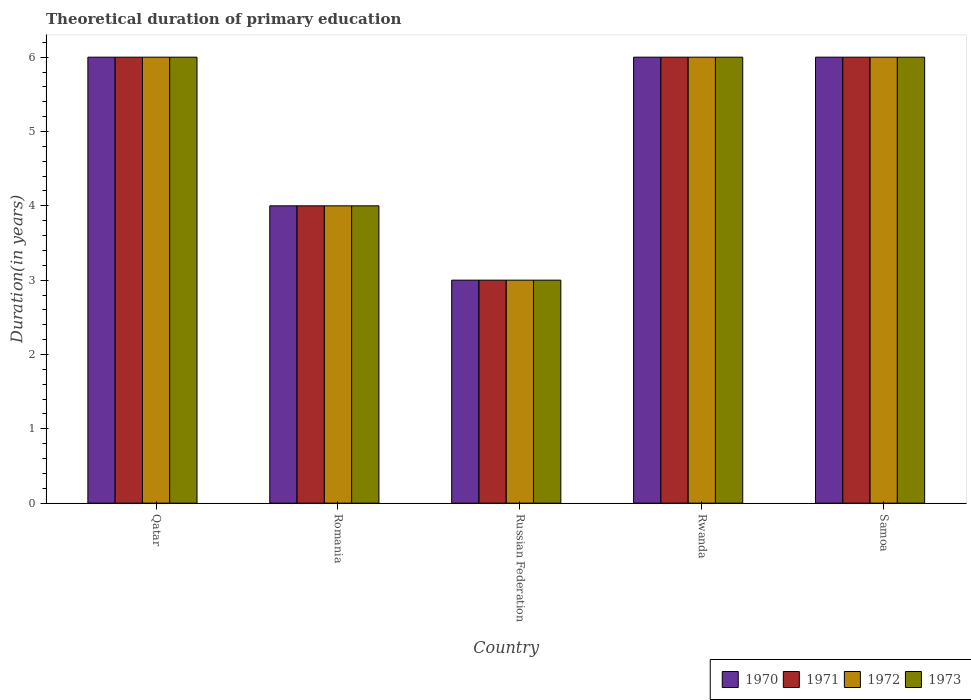How many different coloured bars are there?
Provide a short and direct response. 4. How many groups of bars are there?
Offer a very short reply. 5. Are the number of bars per tick equal to the number of legend labels?
Ensure brevity in your answer.  Yes. What is the label of the 1st group of bars from the left?
Provide a succinct answer. Qatar. In which country was the total theoretical duration of primary education in 1971 maximum?
Offer a terse response. Qatar. In which country was the total theoretical duration of primary education in 1971 minimum?
Your answer should be very brief. Russian Federation. What is the total total theoretical duration of primary education in 1971 in the graph?
Provide a short and direct response. 25. What is the difference between the total theoretical duration of primary education in 1973 in Qatar and that in Romania?
Make the answer very short. 2. In how many countries, is the total theoretical duration of primary education in 1973 greater than 4.2 years?
Offer a terse response. 3. What is the ratio of the total theoretical duration of primary education in 1970 in Rwanda to that in Samoa?
Give a very brief answer. 1. Is the total theoretical duration of primary education in 1970 in Qatar less than that in Russian Federation?
Provide a short and direct response. No. Is the difference between the total theoretical duration of primary education in 1971 in Romania and Samoa greater than the difference between the total theoretical duration of primary education in 1973 in Romania and Samoa?
Give a very brief answer. No. Is it the case that in every country, the sum of the total theoretical duration of primary education in 1970 and total theoretical duration of primary education in 1972 is greater than the sum of total theoretical duration of primary education in 1971 and total theoretical duration of primary education in 1973?
Your answer should be very brief. No. What does the 4th bar from the left in Qatar represents?
Your answer should be very brief. 1973. What does the 3rd bar from the right in Russian Federation represents?
Your answer should be very brief. 1971. How many bars are there?
Make the answer very short. 20. Are all the bars in the graph horizontal?
Your response must be concise. No. What is the difference between two consecutive major ticks on the Y-axis?
Provide a short and direct response. 1. Does the graph contain any zero values?
Offer a terse response. No. Where does the legend appear in the graph?
Offer a very short reply. Bottom right. How many legend labels are there?
Provide a succinct answer. 4. What is the title of the graph?
Provide a short and direct response. Theoretical duration of primary education. What is the label or title of the Y-axis?
Provide a short and direct response. Duration(in years). What is the Duration(in years) in 1970 in Qatar?
Give a very brief answer. 6. What is the Duration(in years) of 1971 in Qatar?
Offer a very short reply. 6. What is the Duration(in years) of 1972 in Qatar?
Offer a very short reply. 6. What is the Duration(in years) of 1970 in Romania?
Provide a short and direct response. 4. What is the Duration(in years) of 1971 in Romania?
Offer a terse response. 4. What is the Duration(in years) of 1972 in Romania?
Your answer should be compact. 4. What is the Duration(in years) of 1973 in Romania?
Make the answer very short. 4. What is the Duration(in years) in 1970 in Russian Federation?
Your answer should be compact. 3. What is the Duration(in years) of 1971 in Russian Federation?
Ensure brevity in your answer.  3. What is the Duration(in years) in 1971 in Rwanda?
Give a very brief answer. 6. What is the Duration(in years) in 1972 in Rwanda?
Keep it short and to the point. 6. What is the Duration(in years) of 1973 in Rwanda?
Offer a terse response. 6. What is the Duration(in years) in 1970 in Samoa?
Offer a very short reply. 6. Across all countries, what is the maximum Duration(in years) of 1971?
Give a very brief answer. 6. Across all countries, what is the maximum Duration(in years) of 1972?
Provide a succinct answer. 6. Across all countries, what is the maximum Duration(in years) of 1973?
Make the answer very short. 6. Across all countries, what is the minimum Duration(in years) in 1971?
Your answer should be very brief. 3. Across all countries, what is the minimum Duration(in years) in 1972?
Your response must be concise. 3. Across all countries, what is the minimum Duration(in years) in 1973?
Provide a succinct answer. 3. What is the total Duration(in years) of 1972 in the graph?
Keep it short and to the point. 25. What is the difference between the Duration(in years) in 1970 in Qatar and that in Romania?
Your response must be concise. 2. What is the difference between the Duration(in years) of 1970 in Qatar and that in Rwanda?
Make the answer very short. 0. What is the difference between the Duration(in years) of 1973 in Qatar and that in Rwanda?
Offer a very short reply. 0. What is the difference between the Duration(in years) in 1970 in Qatar and that in Samoa?
Offer a terse response. 0. What is the difference between the Duration(in years) in 1971 in Qatar and that in Samoa?
Offer a terse response. 0. What is the difference between the Duration(in years) of 1972 in Qatar and that in Samoa?
Provide a short and direct response. 0. What is the difference between the Duration(in years) of 1970 in Romania and that in Russian Federation?
Give a very brief answer. 1. What is the difference between the Duration(in years) of 1971 in Romania and that in Russian Federation?
Keep it short and to the point. 1. What is the difference between the Duration(in years) in 1972 in Romania and that in Rwanda?
Your response must be concise. -2. What is the difference between the Duration(in years) of 1973 in Romania and that in Samoa?
Provide a short and direct response. -2. What is the difference between the Duration(in years) in 1970 in Russian Federation and that in Rwanda?
Your answer should be very brief. -3. What is the difference between the Duration(in years) of 1971 in Russian Federation and that in Rwanda?
Make the answer very short. -3. What is the difference between the Duration(in years) of 1973 in Russian Federation and that in Rwanda?
Provide a succinct answer. -3. What is the difference between the Duration(in years) of 1971 in Russian Federation and that in Samoa?
Make the answer very short. -3. What is the difference between the Duration(in years) of 1972 in Russian Federation and that in Samoa?
Offer a very short reply. -3. What is the difference between the Duration(in years) of 1973 in Russian Federation and that in Samoa?
Your answer should be very brief. -3. What is the difference between the Duration(in years) in 1970 in Rwanda and that in Samoa?
Make the answer very short. 0. What is the difference between the Duration(in years) in 1971 in Rwanda and that in Samoa?
Keep it short and to the point. 0. What is the difference between the Duration(in years) in 1970 in Qatar and the Duration(in years) in 1973 in Romania?
Ensure brevity in your answer.  2. What is the difference between the Duration(in years) in 1971 in Qatar and the Duration(in years) in 1973 in Romania?
Your response must be concise. 2. What is the difference between the Duration(in years) in 1970 in Qatar and the Duration(in years) in 1973 in Russian Federation?
Offer a terse response. 3. What is the difference between the Duration(in years) of 1971 in Qatar and the Duration(in years) of 1973 in Russian Federation?
Make the answer very short. 3. What is the difference between the Duration(in years) of 1972 in Qatar and the Duration(in years) of 1973 in Russian Federation?
Provide a short and direct response. 3. What is the difference between the Duration(in years) of 1970 in Qatar and the Duration(in years) of 1972 in Rwanda?
Ensure brevity in your answer.  0. What is the difference between the Duration(in years) in 1971 in Qatar and the Duration(in years) in 1973 in Rwanda?
Your answer should be compact. 0. What is the difference between the Duration(in years) in 1972 in Qatar and the Duration(in years) in 1973 in Rwanda?
Your response must be concise. 0. What is the difference between the Duration(in years) of 1970 in Qatar and the Duration(in years) of 1972 in Samoa?
Your response must be concise. 0. What is the difference between the Duration(in years) in 1972 in Qatar and the Duration(in years) in 1973 in Samoa?
Offer a terse response. 0. What is the difference between the Duration(in years) of 1970 in Romania and the Duration(in years) of 1973 in Russian Federation?
Offer a very short reply. 1. What is the difference between the Duration(in years) of 1971 in Romania and the Duration(in years) of 1972 in Russian Federation?
Keep it short and to the point. 1. What is the difference between the Duration(in years) of 1971 in Romania and the Duration(in years) of 1973 in Russian Federation?
Offer a very short reply. 1. What is the difference between the Duration(in years) of 1970 in Romania and the Duration(in years) of 1972 in Rwanda?
Offer a very short reply. -2. What is the difference between the Duration(in years) of 1971 in Romania and the Duration(in years) of 1972 in Rwanda?
Your response must be concise. -2. What is the difference between the Duration(in years) of 1971 in Romania and the Duration(in years) of 1973 in Rwanda?
Your answer should be very brief. -2. What is the difference between the Duration(in years) of 1970 in Romania and the Duration(in years) of 1971 in Samoa?
Your answer should be compact. -2. What is the difference between the Duration(in years) in 1970 in Romania and the Duration(in years) in 1972 in Samoa?
Offer a very short reply. -2. What is the difference between the Duration(in years) of 1971 in Romania and the Duration(in years) of 1972 in Samoa?
Your response must be concise. -2. What is the difference between the Duration(in years) in 1971 in Romania and the Duration(in years) in 1973 in Samoa?
Offer a terse response. -2. What is the difference between the Duration(in years) in 1970 in Russian Federation and the Duration(in years) in 1971 in Rwanda?
Provide a short and direct response. -3. What is the difference between the Duration(in years) in 1970 in Russian Federation and the Duration(in years) in 1972 in Rwanda?
Make the answer very short. -3. What is the difference between the Duration(in years) of 1971 in Russian Federation and the Duration(in years) of 1972 in Rwanda?
Keep it short and to the point. -3. What is the difference between the Duration(in years) in 1970 in Russian Federation and the Duration(in years) in 1972 in Samoa?
Provide a short and direct response. -3. What is the difference between the Duration(in years) in 1971 in Russian Federation and the Duration(in years) in 1972 in Samoa?
Give a very brief answer. -3. What is the difference between the Duration(in years) in 1971 in Russian Federation and the Duration(in years) in 1973 in Samoa?
Offer a terse response. -3. What is the difference between the Duration(in years) of 1972 in Russian Federation and the Duration(in years) of 1973 in Samoa?
Give a very brief answer. -3. What is the difference between the Duration(in years) in 1970 in Rwanda and the Duration(in years) in 1973 in Samoa?
Offer a terse response. 0. What is the difference between the Duration(in years) in 1972 in Rwanda and the Duration(in years) in 1973 in Samoa?
Offer a very short reply. 0. What is the average Duration(in years) of 1972 per country?
Your answer should be very brief. 5. What is the average Duration(in years) of 1973 per country?
Make the answer very short. 5. What is the difference between the Duration(in years) of 1970 and Duration(in years) of 1971 in Qatar?
Offer a very short reply. 0. What is the difference between the Duration(in years) of 1970 and Duration(in years) of 1972 in Qatar?
Offer a terse response. 0. What is the difference between the Duration(in years) of 1971 and Duration(in years) of 1972 in Qatar?
Your answer should be compact. 0. What is the difference between the Duration(in years) in 1971 and Duration(in years) in 1973 in Qatar?
Ensure brevity in your answer.  0. What is the difference between the Duration(in years) of 1970 and Duration(in years) of 1973 in Romania?
Offer a terse response. 0. What is the difference between the Duration(in years) of 1970 and Duration(in years) of 1971 in Russian Federation?
Ensure brevity in your answer.  0. What is the difference between the Duration(in years) in 1970 and Duration(in years) in 1973 in Russian Federation?
Ensure brevity in your answer.  0. What is the difference between the Duration(in years) of 1972 and Duration(in years) of 1973 in Russian Federation?
Your answer should be compact. 0. What is the difference between the Duration(in years) of 1970 and Duration(in years) of 1971 in Rwanda?
Offer a terse response. 0. What is the difference between the Duration(in years) in 1971 and Duration(in years) in 1973 in Rwanda?
Your answer should be very brief. 0. What is the difference between the Duration(in years) in 1972 and Duration(in years) in 1973 in Rwanda?
Keep it short and to the point. 0. What is the difference between the Duration(in years) in 1970 and Duration(in years) in 1973 in Samoa?
Your response must be concise. 0. What is the difference between the Duration(in years) in 1971 and Duration(in years) in 1973 in Samoa?
Give a very brief answer. 0. What is the ratio of the Duration(in years) of 1970 in Qatar to that in Romania?
Your response must be concise. 1.5. What is the ratio of the Duration(in years) of 1971 in Qatar to that in Romania?
Your answer should be very brief. 1.5. What is the ratio of the Duration(in years) in 1973 in Qatar to that in Romania?
Make the answer very short. 1.5. What is the ratio of the Duration(in years) of 1971 in Qatar to that in Russian Federation?
Provide a succinct answer. 2. What is the ratio of the Duration(in years) of 1970 in Qatar to that in Rwanda?
Your answer should be compact. 1. What is the ratio of the Duration(in years) in 1973 in Qatar to that in Rwanda?
Make the answer very short. 1. What is the ratio of the Duration(in years) of 1971 in Qatar to that in Samoa?
Provide a succinct answer. 1. What is the ratio of the Duration(in years) in 1972 in Qatar to that in Samoa?
Offer a terse response. 1. What is the ratio of the Duration(in years) in 1973 in Romania to that in Russian Federation?
Make the answer very short. 1.33. What is the ratio of the Duration(in years) of 1970 in Romania to that in Rwanda?
Offer a terse response. 0.67. What is the ratio of the Duration(in years) in 1973 in Romania to that in Rwanda?
Give a very brief answer. 0.67. What is the ratio of the Duration(in years) of 1970 in Romania to that in Samoa?
Make the answer very short. 0.67. What is the ratio of the Duration(in years) of 1971 in Romania to that in Samoa?
Make the answer very short. 0.67. What is the ratio of the Duration(in years) of 1972 in Romania to that in Samoa?
Make the answer very short. 0.67. What is the ratio of the Duration(in years) in 1973 in Romania to that in Samoa?
Your answer should be compact. 0.67. What is the ratio of the Duration(in years) in 1970 in Russian Federation to that in Rwanda?
Ensure brevity in your answer.  0.5. What is the ratio of the Duration(in years) in 1971 in Russian Federation to that in Rwanda?
Make the answer very short. 0.5. What is the ratio of the Duration(in years) in 1971 in Russian Federation to that in Samoa?
Give a very brief answer. 0.5. What is the ratio of the Duration(in years) in 1973 in Russian Federation to that in Samoa?
Your response must be concise. 0.5. What is the ratio of the Duration(in years) in 1971 in Rwanda to that in Samoa?
Offer a very short reply. 1. What is the ratio of the Duration(in years) of 1972 in Rwanda to that in Samoa?
Keep it short and to the point. 1. What is the ratio of the Duration(in years) of 1973 in Rwanda to that in Samoa?
Make the answer very short. 1. What is the difference between the highest and the second highest Duration(in years) in 1970?
Provide a short and direct response. 0. What is the difference between the highest and the second highest Duration(in years) of 1972?
Make the answer very short. 0. What is the difference between the highest and the second highest Duration(in years) in 1973?
Provide a short and direct response. 0. What is the difference between the highest and the lowest Duration(in years) in 1971?
Give a very brief answer. 3. What is the difference between the highest and the lowest Duration(in years) in 1972?
Offer a terse response. 3. 